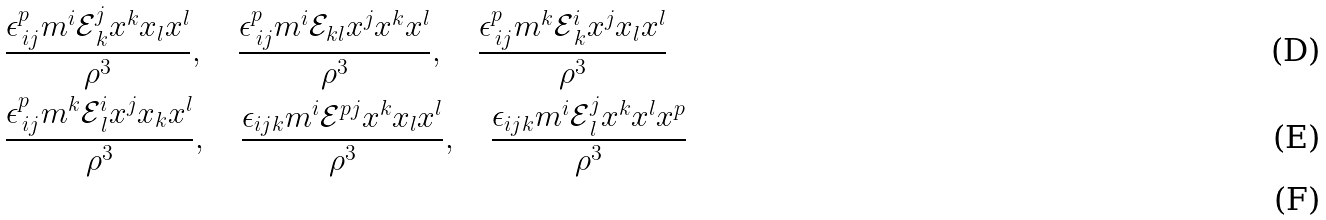<formula> <loc_0><loc_0><loc_500><loc_500>& \frac { \epsilon ^ { p } _ { \, i j } m ^ { i } \mathcal { E } ^ { j } _ { \, k } x ^ { k } x _ { l } x ^ { l } } { \rho ^ { 3 } } , \quad \frac { \epsilon ^ { p } _ { \, i j } m ^ { i } \mathcal { E } _ { k l } x ^ { j } x ^ { k } x ^ { l } } { \rho ^ { 3 } } , \quad \frac { \epsilon ^ { p } _ { \, i j } m ^ { k } \mathcal { E } ^ { i } _ { \, k } x ^ { j } x _ { l } x ^ { l } } { \rho ^ { 3 } } \\ & \frac { \epsilon ^ { p } _ { \, i j } m ^ { k } \mathcal { E } ^ { i } _ { \, l } x ^ { j } x _ { k } x ^ { l } } { \rho ^ { 3 } } , \quad \frac { \epsilon _ { i j k } m ^ { i } \mathcal { E } ^ { p j } x ^ { k } x _ { l } x ^ { l } } { \rho ^ { 3 } } , \quad \frac { \epsilon _ { i j k } m ^ { i } \mathcal { E } ^ { j } _ { \, l } x ^ { k } x ^ { l } x ^ { p } } { \rho ^ { 3 } } \\</formula> 